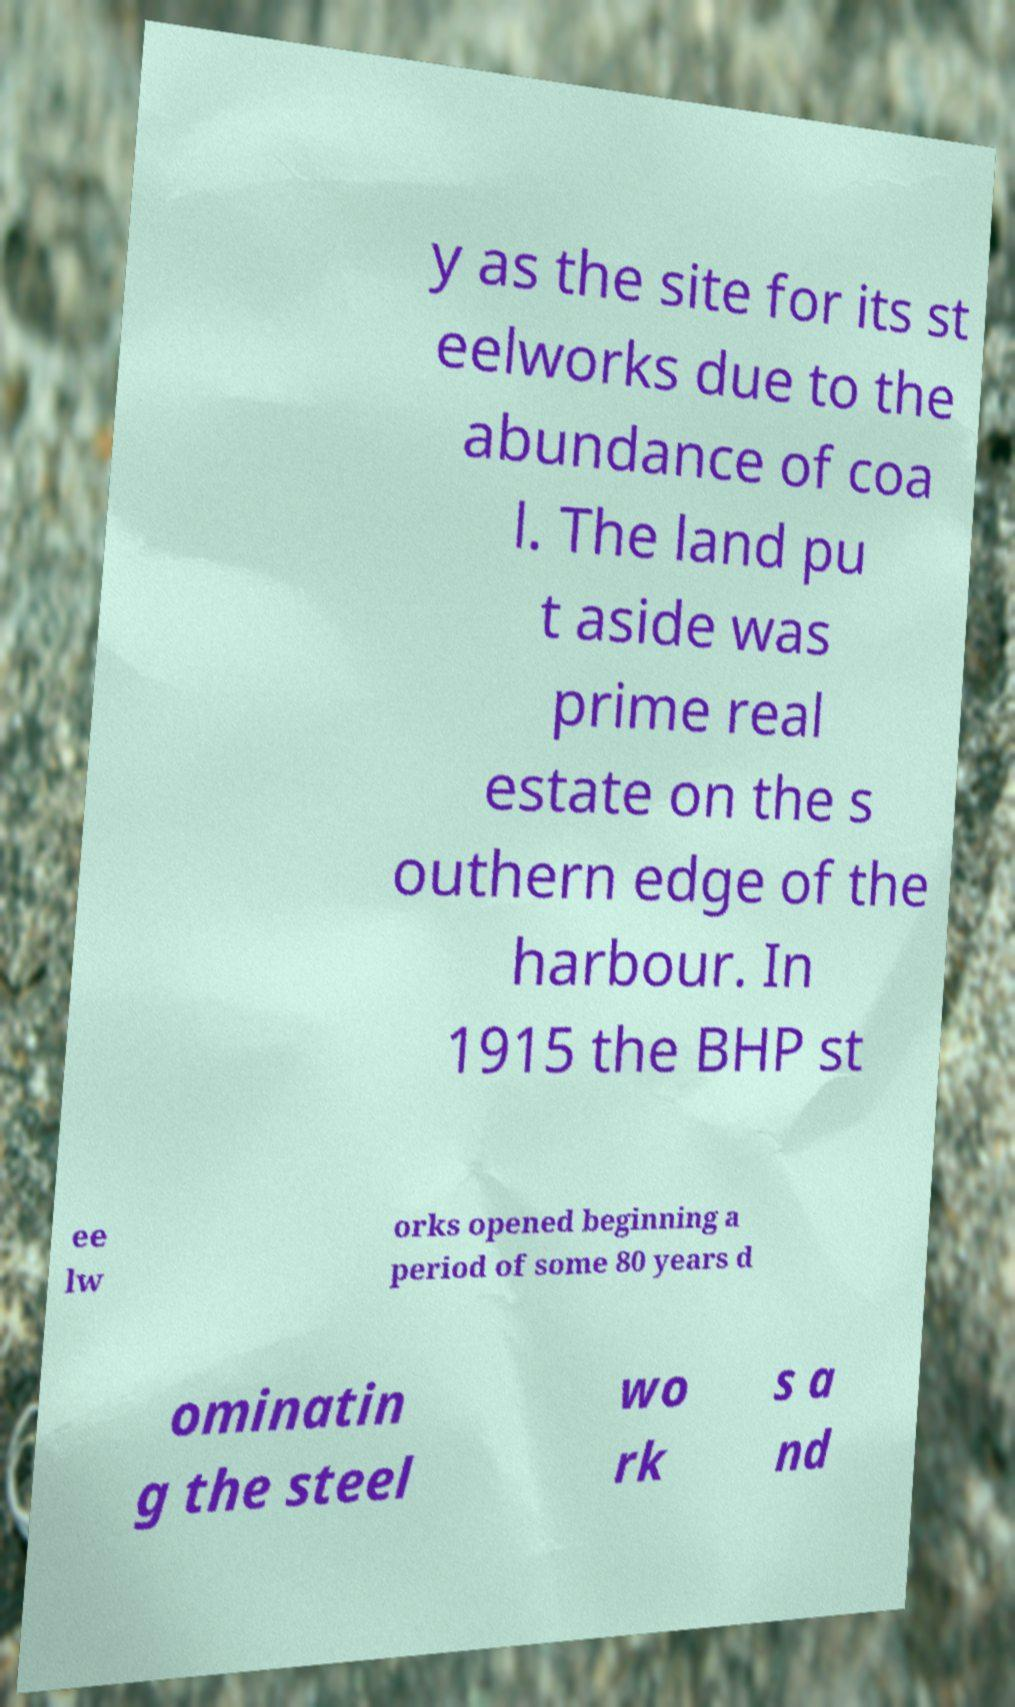Can you accurately transcribe the text from the provided image for me? y as the site for its st eelworks due to the abundance of coa l. The land pu t aside was prime real estate on the s outhern edge of the harbour. In 1915 the BHP st ee lw orks opened beginning a period of some 80 years d ominatin g the steel wo rk s a nd 